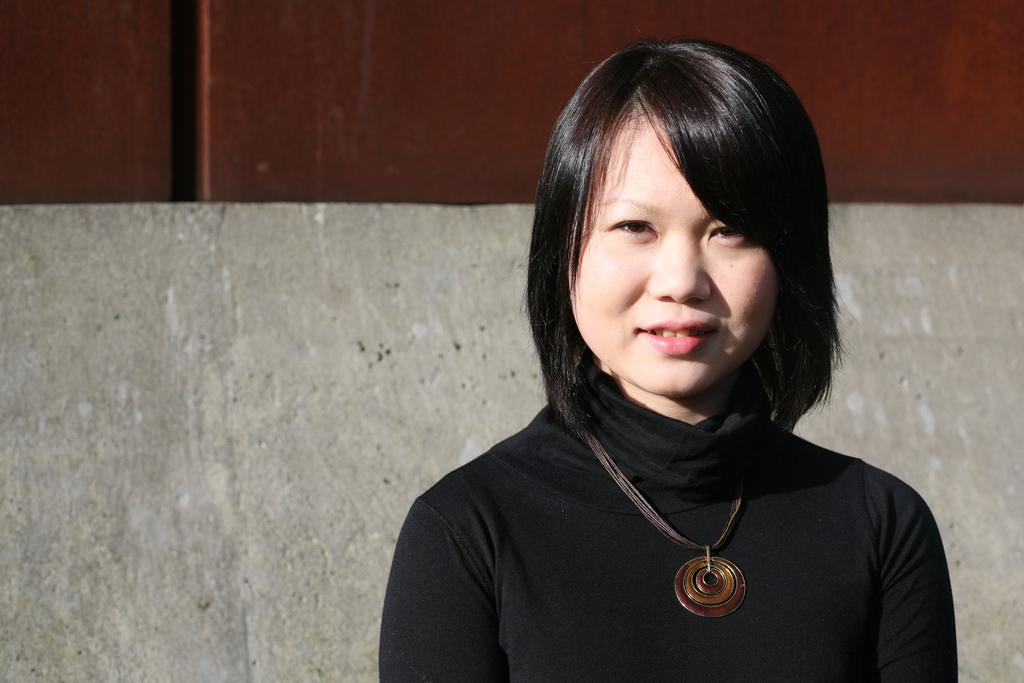Who or what is present in the image? There is a person in the image. What is the person wearing? The person is wearing a black dress. What can be seen in the background of the image? There is a wall and an object with a pole in the background of the image. What type of train can be seen in the image? There is no train present in the image. Is the person in the image a spy? There is no information in the image to suggest that the person is a spy. 